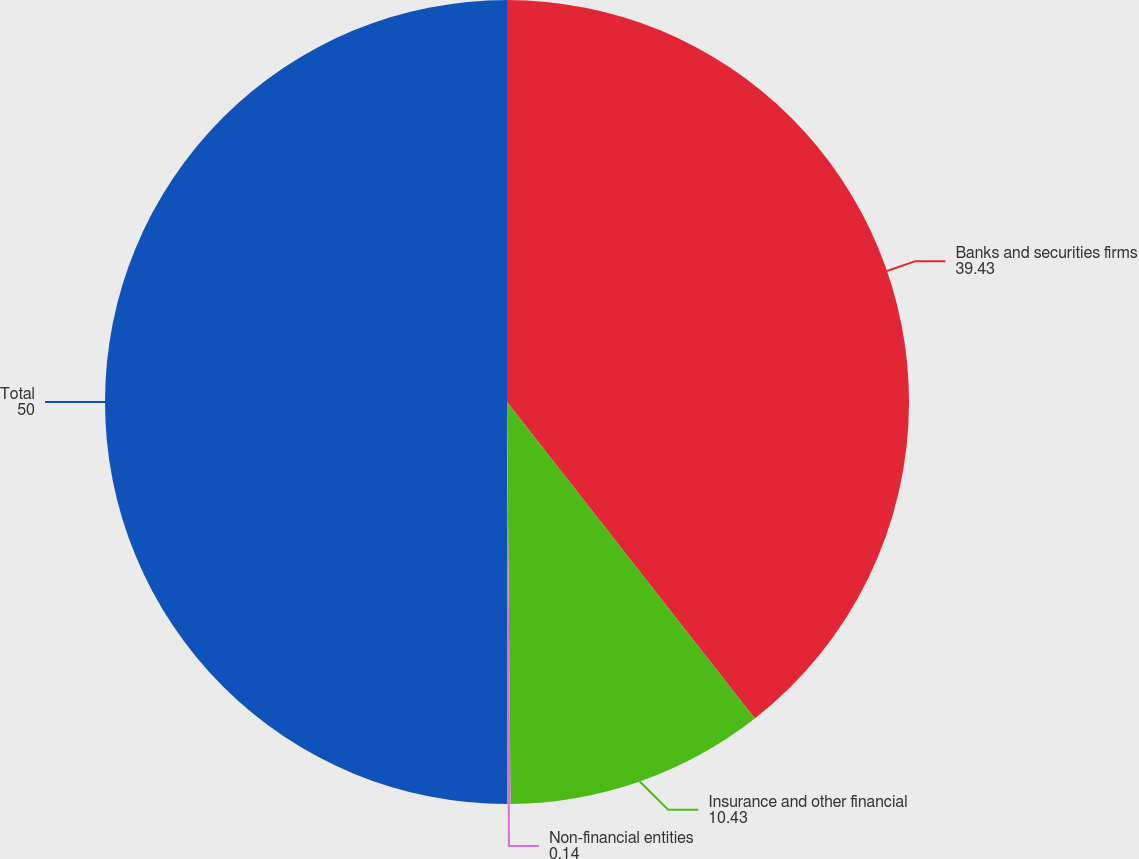Convert chart. <chart><loc_0><loc_0><loc_500><loc_500><pie_chart><fcel>Banks and securities firms<fcel>Insurance and other financial<fcel>Non-financial entities<fcel>Total<nl><fcel>39.43%<fcel>10.43%<fcel>0.14%<fcel>50.0%<nl></chart> 